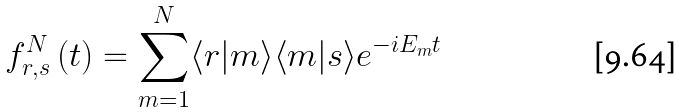Convert formula to latex. <formula><loc_0><loc_0><loc_500><loc_500>f _ { r , s } ^ { N } \left ( t \right ) = \sum _ { m = 1 } ^ { N } \langle r | m \rangle \langle m | s \rangle e ^ { - i E _ { m } t }</formula> 